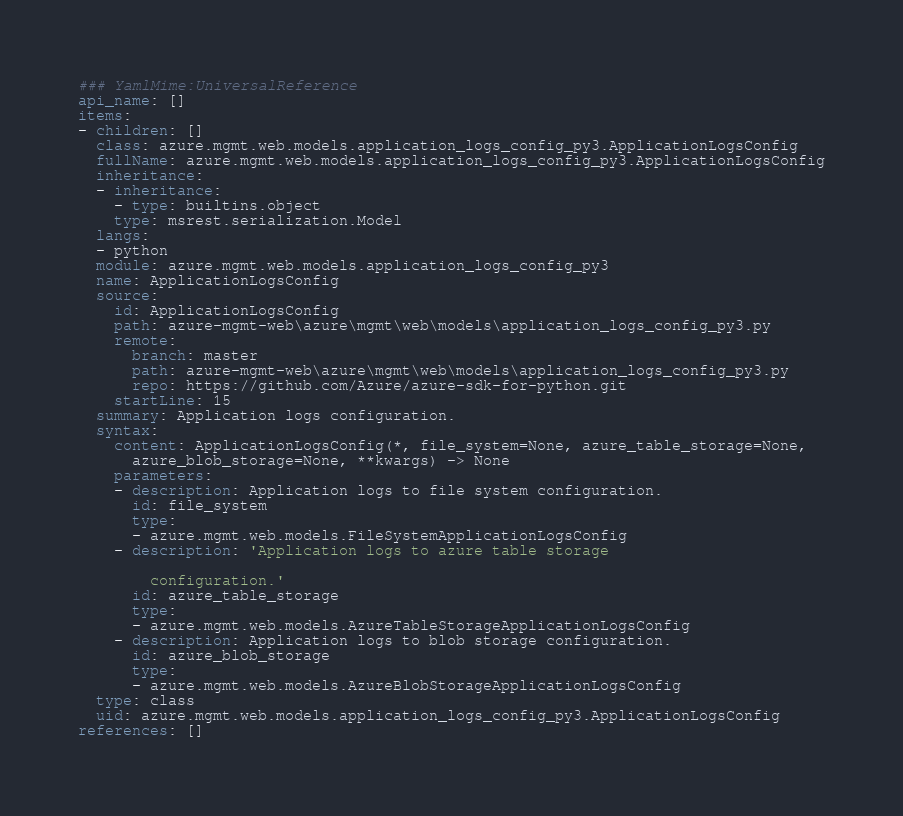<code> <loc_0><loc_0><loc_500><loc_500><_YAML_>### YamlMime:UniversalReference
api_name: []
items:
- children: []
  class: azure.mgmt.web.models.application_logs_config_py3.ApplicationLogsConfig
  fullName: azure.mgmt.web.models.application_logs_config_py3.ApplicationLogsConfig
  inheritance:
  - inheritance:
    - type: builtins.object
    type: msrest.serialization.Model
  langs:
  - python
  module: azure.mgmt.web.models.application_logs_config_py3
  name: ApplicationLogsConfig
  source:
    id: ApplicationLogsConfig
    path: azure-mgmt-web\azure\mgmt\web\models\application_logs_config_py3.py
    remote:
      branch: master
      path: azure-mgmt-web\azure\mgmt\web\models\application_logs_config_py3.py
      repo: https://github.com/Azure/azure-sdk-for-python.git
    startLine: 15
  summary: Application logs configuration.
  syntax:
    content: ApplicationLogsConfig(*, file_system=None, azure_table_storage=None,
      azure_blob_storage=None, **kwargs) -> None
    parameters:
    - description: Application logs to file system configuration.
      id: file_system
      type:
      - azure.mgmt.web.models.FileSystemApplicationLogsConfig
    - description: 'Application logs to azure table storage

        configuration.'
      id: azure_table_storage
      type:
      - azure.mgmt.web.models.AzureTableStorageApplicationLogsConfig
    - description: Application logs to blob storage configuration.
      id: azure_blob_storage
      type:
      - azure.mgmt.web.models.AzureBlobStorageApplicationLogsConfig
  type: class
  uid: azure.mgmt.web.models.application_logs_config_py3.ApplicationLogsConfig
references: []
</code> 